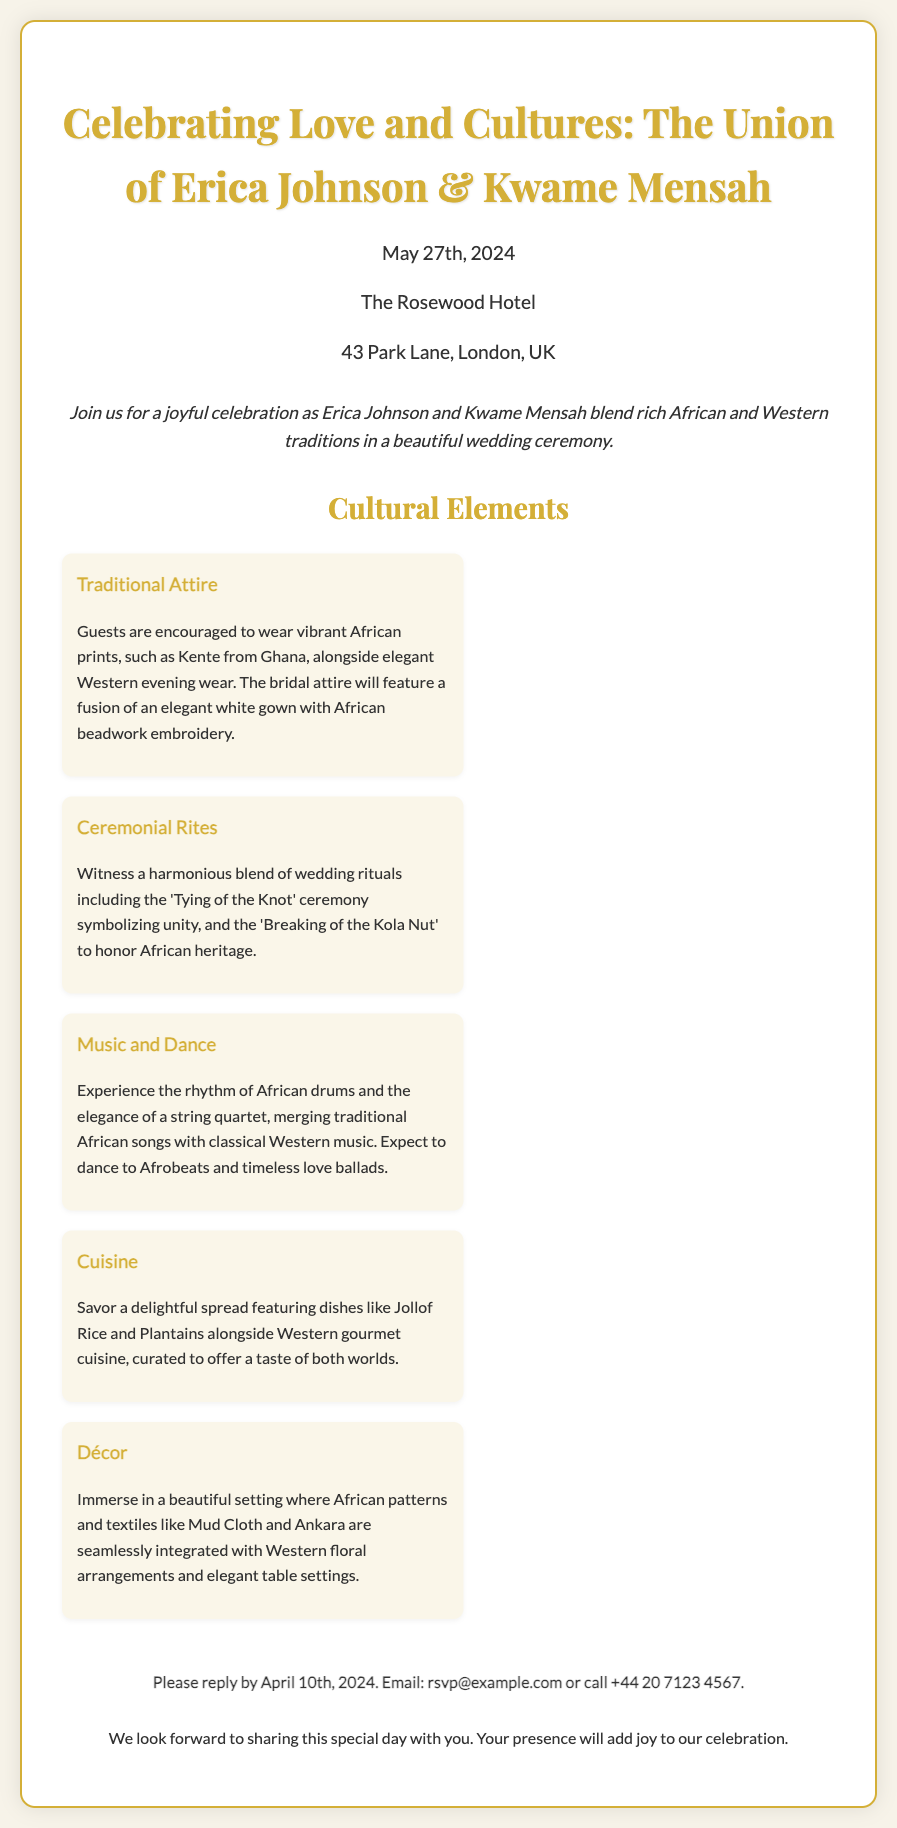What are the names of the couple? The invitation prominently displays the names of the couple getting married, which are Erica Johnson and Kwame Mensah.
Answer: Erica Johnson & Kwame Mensah What is the wedding date? The document specifies the date of the wedding celebration, which is printed clearly for guests.
Answer: May 27th, 2024 Where is the wedding venue? The invitation includes the location of the wedding, detailing the venue and its address.
Answer: The Rosewood Hotel, 43 Park Lane, London, UK What is the RSVP deadline? The invitation mentions the last date by which guests should respond to the invitation.
Answer: April 10th, 2024 What type of attire is encouraged? The document suggests specific attire for the guests, emphasizing cultural significance and style.
Answer: Vibrant African prints What ceremony symbolizes unity? The invitation describes a traditional wedding rite that signifies the bond between the couple.
Answer: Tying of the Knot Which two cuisines are featured? The invitation highlights the diversity in food offerings, including dishes from both cultures.
Answer: Jollof Rice and Western gourmet cuisine What type of music will be played? The document outlines the musical entertainment planned for the wedding, combining various genres.
Answer: African drums and a string quartet What is integrated into the décor? The invitation details elements that form part of the wedding decorations, showcasing cultural artistry.
Answer: African patterns and textiles 